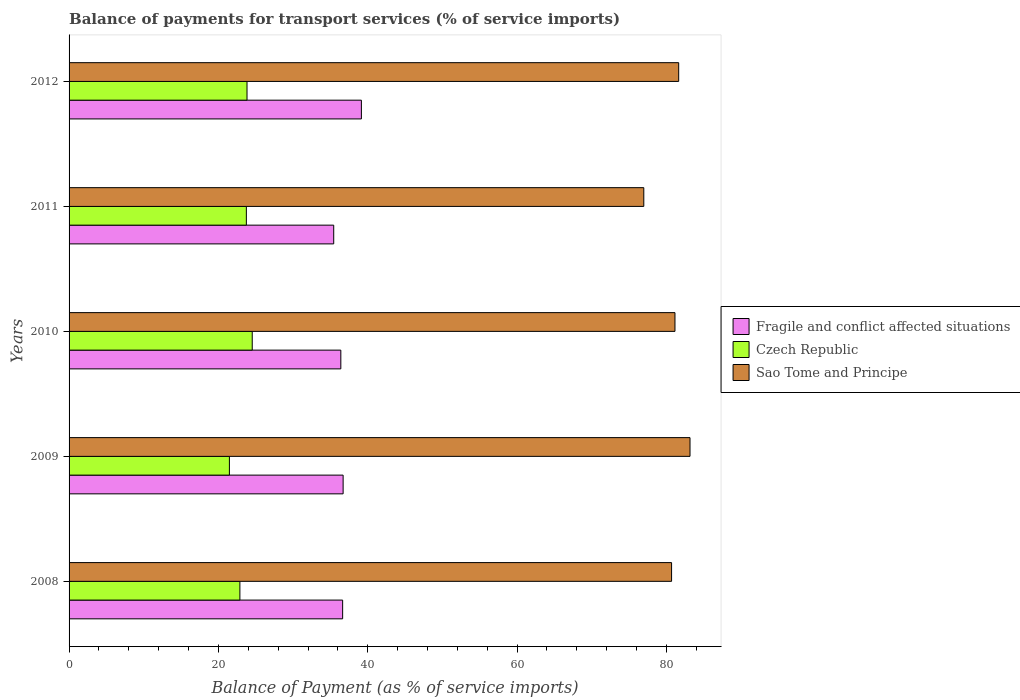Are the number of bars per tick equal to the number of legend labels?
Give a very brief answer. Yes. How many bars are there on the 3rd tick from the top?
Keep it short and to the point. 3. How many bars are there on the 5th tick from the bottom?
Ensure brevity in your answer.  3. What is the balance of payments for transport services in Sao Tome and Principe in 2009?
Offer a very short reply. 83.15. Across all years, what is the maximum balance of payments for transport services in Czech Republic?
Your response must be concise. 24.53. Across all years, what is the minimum balance of payments for transport services in Czech Republic?
Provide a succinct answer. 21.47. What is the total balance of payments for transport services in Fragile and conflict affected situations in the graph?
Your answer should be compact. 184.31. What is the difference between the balance of payments for transport services in Fragile and conflict affected situations in 2009 and that in 2011?
Your answer should be compact. 1.26. What is the difference between the balance of payments for transport services in Sao Tome and Principe in 2009 and the balance of payments for transport services in Czech Republic in 2012?
Your response must be concise. 59.32. What is the average balance of payments for transport services in Sao Tome and Principe per year?
Keep it short and to the point. 80.72. In the year 2009, what is the difference between the balance of payments for transport services in Czech Republic and balance of payments for transport services in Sao Tome and Principe?
Give a very brief answer. -61.68. In how many years, is the balance of payments for transport services in Sao Tome and Principe greater than 64 %?
Offer a terse response. 5. What is the ratio of the balance of payments for transport services in Czech Republic in 2008 to that in 2009?
Offer a very short reply. 1.07. Is the balance of payments for transport services in Czech Republic in 2008 less than that in 2012?
Offer a terse response. Yes. What is the difference between the highest and the second highest balance of payments for transport services in Sao Tome and Principe?
Provide a succinct answer. 1.52. What is the difference between the highest and the lowest balance of payments for transport services in Sao Tome and Principe?
Provide a succinct answer. 6.19. In how many years, is the balance of payments for transport services in Sao Tome and Principe greater than the average balance of payments for transport services in Sao Tome and Principe taken over all years?
Your response must be concise. 3. What does the 1st bar from the top in 2011 represents?
Offer a very short reply. Sao Tome and Principe. What does the 3rd bar from the bottom in 2008 represents?
Give a very brief answer. Sao Tome and Principe. How many bars are there?
Provide a short and direct response. 15. What is the title of the graph?
Keep it short and to the point. Balance of payments for transport services (% of service imports). What is the label or title of the X-axis?
Provide a short and direct response. Balance of Payment (as % of service imports). What is the Balance of Payment (as % of service imports) of Fragile and conflict affected situations in 2008?
Make the answer very short. 36.64. What is the Balance of Payment (as % of service imports) in Czech Republic in 2008?
Your response must be concise. 22.88. What is the Balance of Payment (as % of service imports) of Sao Tome and Principe in 2008?
Provide a short and direct response. 80.69. What is the Balance of Payment (as % of service imports) of Fragile and conflict affected situations in 2009?
Offer a very short reply. 36.7. What is the Balance of Payment (as % of service imports) of Czech Republic in 2009?
Offer a very short reply. 21.47. What is the Balance of Payment (as % of service imports) in Sao Tome and Principe in 2009?
Give a very brief answer. 83.15. What is the Balance of Payment (as % of service imports) in Fragile and conflict affected situations in 2010?
Keep it short and to the point. 36.39. What is the Balance of Payment (as % of service imports) in Czech Republic in 2010?
Offer a terse response. 24.53. What is the Balance of Payment (as % of service imports) in Sao Tome and Principe in 2010?
Your answer should be very brief. 81.14. What is the Balance of Payment (as % of service imports) in Fragile and conflict affected situations in 2011?
Offer a very short reply. 35.44. What is the Balance of Payment (as % of service imports) in Czech Republic in 2011?
Give a very brief answer. 23.74. What is the Balance of Payment (as % of service imports) of Sao Tome and Principe in 2011?
Provide a short and direct response. 76.96. What is the Balance of Payment (as % of service imports) of Fragile and conflict affected situations in 2012?
Provide a short and direct response. 39.15. What is the Balance of Payment (as % of service imports) in Czech Republic in 2012?
Offer a very short reply. 23.83. What is the Balance of Payment (as % of service imports) of Sao Tome and Principe in 2012?
Give a very brief answer. 81.64. Across all years, what is the maximum Balance of Payment (as % of service imports) of Fragile and conflict affected situations?
Your answer should be very brief. 39.15. Across all years, what is the maximum Balance of Payment (as % of service imports) of Czech Republic?
Provide a succinct answer. 24.53. Across all years, what is the maximum Balance of Payment (as % of service imports) of Sao Tome and Principe?
Keep it short and to the point. 83.15. Across all years, what is the minimum Balance of Payment (as % of service imports) of Fragile and conflict affected situations?
Keep it short and to the point. 35.44. Across all years, what is the minimum Balance of Payment (as % of service imports) of Czech Republic?
Your response must be concise. 21.47. Across all years, what is the minimum Balance of Payment (as % of service imports) in Sao Tome and Principe?
Your answer should be compact. 76.96. What is the total Balance of Payment (as % of service imports) in Fragile and conflict affected situations in the graph?
Make the answer very short. 184.31. What is the total Balance of Payment (as % of service imports) in Czech Republic in the graph?
Provide a short and direct response. 116.45. What is the total Balance of Payment (as % of service imports) of Sao Tome and Principe in the graph?
Offer a very short reply. 403.58. What is the difference between the Balance of Payment (as % of service imports) of Fragile and conflict affected situations in 2008 and that in 2009?
Make the answer very short. -0.07. What is the difference between the Balance of Payment (as % of service imports) of Czech Republic in 2008 and that in 2009?
Ensure brevity in your answer.  1.4. What is the difference between the Balance of Payment (as % of service imports) of Sao Tome and Principe in 2008 and that in 2009?
Ensure brevity in your answer.  -2.47. What is the difference between the Balance of Payment (as % of service imports) of Fragile and conflict affected situations in 2008 and that in 2010?
Offer a terse response. 0.24. What is the difference between the Balance of Payment (as % of service imports) of Czech Republic in 2008 and that in 2010?
Give a very brief answer. -1.65. What is the difference between the Balance of Payment (as % of service imports) in Sao Tome and Principe in 2008 and that in 2010?
Make the answer very short. -0.45. What is the difference between the Balance of Payment (as % of service imports) in Fragile and conflict affected situations in 2008 and that in 2011?
Ensure brevity in your answer.  1.2. What is the difference between the Balance of Payment (as % of service imports) in Czech Republic in 2008 and that in 2011?
Make the answer very short. -0.87. What is the difference between the Balance of Payment (as % of service imports) in Sao Tome and Principe in 2008 and that in 2011?
Provide a short and direct response. 3.72. What is the difference between the Balance of Payment (as % of service imports) of Fragile and conflict affected situations in 2008 and that in 2012?
Offer a terse response. -2.51. What is the difference between the Balance of Payment (as % of service imports) of Czech Republic in 2008 and that in 2012?
Your response must be concise. -0.95. What is the difference between the Balance of Payment (as % of service imports) of Sao Tome and Principe in 2008 and that in 2012?
Your answer should be very brief. -0.95. What is the difference between the Balance of Payment (as % of service imports) of Fragile and conflict affected situations in 2009 and that in 2010?
Offer a very short reply. 0.31. What is the difference between the Balance of Payment (as % of service imports) in Czech Republic in 2009 and that in 2010?
Ensure brevity in your answer.  -3.06. What is the difference between the Balance of Payment (as % of service imports) of Sao Tome and Principe in 2009 and that in 2010?
Keep it short and to the point. 2.01. What is the difference between the Balance of Payment (as % of service imports) of Fragile and conflict affected situations in 2009 and that in 2011?
Offer a terse response. 1.26. What is the difference between the Balance of Payment (as % of service imports) in Czech Republic in 2009 and that in 2011?
Your response must be concise. -2.27. What is the difference between the Balance of Payment (as % of service imports) in Sao Tome and Principe in 2009 and that in 2011?
Keep it short and to the point. 6.19. What is the difference between the Balance of Payment (as % of service imports) of Fragile and conflict affected situations in 2009 and that in 2012?
Keep it short and to the point. -2.45. What is the difference between the Balance of Payment (as % of service imports) in Czech Republic in 2009 and that in 2012?
Offer a very short reply. -2.36. What is the difference between the Balance of Payment (as % of service imports) of Sao Tome and Principe in 2009 and that in 2012?
Make the answer very short. 1.52. What is the difference between the Balance of Payment (as % of service imports) in Fragile and conflict affected situations in 2010 and that in 2011?
Provide a succinct answer. 0.95. What is the difference between the Balance of Payment (as % of service imports) of Czech Republic in 2010 and that in 2011?
Provide a succinct answer. 0.79. What is the difference between the Balance of Payment (as % of service imports) of Sao Tome and Principe in 2010 and that in 2011?
Keep it short and to the point. 4.17. What is the difference between the Balance of Payment (as % of service imports) in Fragile and conflict affected situations in 2010 and that in 2012?
Your response must be concise. -2.75. What is the difference between the Balance of Payment (as % of service imports) in Czech Republic in 2010 and that in 2012?
Ensure brevity in your answer.  0.7. What is the difference between the Balance of Payment (as % of service imports) in Sao Tome and Principe in 2010 and that in 2012?
Make the answer very short. -0.5. What is the difference between the Balance of Payment (as % of service imports) of Fragile and conflict affected situations in 2011 and that in 2012?
Make the answer very short. -3.71. What is the difference between the Balance of Payment (as % of service imports) of Czech Republic in 2011 and that in 2012?
Your answer should be compact. -0.09. What is the difference between the Balance of Payment (as % of service imports) of Sao Tome and Principe in 2011 and that in 2012?
Offer a terse response. -4.67. What is the difference between the Balance of Payment (as % of service imports) in Fragile and conflict affected situations in 2008 and the Balance of Payment (as % of service imports) in Czech Republic in 2009?
Keep it short and to the point. 15.16. What is the difference between the Balance of Payment (as % of service imports) in Fragile and conflict affected situations in 2008 and the Balance of Payment (as % of service imports) in Sao Tome and Principe in 2009?
Your answer should be compact. -46.52. What is the difference between the Balance of Payment (as % of service imports) of Czech Republic in 2008 and the Balance of Payment (as % of service imports) of Sao Tome and Principe in 2009?
Offer a very short reply. -60.28. What is the difference between the Balance of Payment (as % of service imports) in Fragile and conflict affected situations in 2008 and the Balance of Payment (as % of service imports) in Czech Republic in 2010?
Provide a succinct answer. 12.11. What is the difference between the Balance of Payment (as % of service imports) in Fragile and conflict affected situations in 2008 and the Balance of Payment (as % of service imports) in Sao Tome and Principe in 2010?
Your answer should be compact. -44.5. What is the difference between the Balance of Payment (as % of service imports) of Czech Republic in 2008 and the Balance of Payment (as % of service imports) of Sao Tome and Principe in 2010?
Your answer should be compact. -58.26. What is the difference between the Balance of Payment (as % of service imports) of Fragile and conflict affected situations in 2008 and the Balance of Payment (as % of service imports) of Czech Republic in 2011?
Your answer should be very brief. 12.89. What is the difference between the Balance of Payment (as % of service imports) in Fragile and conflict affected situations in 2008 and the Balance of Payment (as % of service imports) in Sao Tome and Principe in 2011?
Offer a very short reply. -40.33. What is the difference between the Balance of Payment (as % of service imports) of Czech Republic in 2008 and the Balance of Payment (as % of service imports) of Sao Tome and Principe in 2011?
Make the answer very short. -54.09. What is the difference between the Balance of Payment (as % of service imports) in Fragile and conflict affected situations in 2008 and the Balance of Payment (as % of service imports) in Czech Republic in 2012?
Keep it short and to the point. 12.81. What is the difference between the Balance of Payment (as % of service imports) in Fragile and conflict affected situations in 2008 and the Balance of Payment (as % of service imports) in Sao Tome and Principe in 2012?
Provide a succinct answer. -45. What is the difference between the Balance of Payment (as % of service imports) in Czech Republic in 2008 and the Balance of Payment (as % of service imports) in Sao Tome and Principe in 2012?
Offer a terse response. -58.76. What is the difference between the Balance of Payment (as % of service imports) of Fragile and conflict affected situations in 2009 and the Balance of Payment (as % of service imports) of Czech Republic in 2010?
Keep it short and to the point. 12.17. What is the difference between the Balance of Payment (as % of service imports) of Fragile and conflict affected situations in 2009 and the Balance of Payment (as % of service imports) of Sao Tome and Principe in 2010?
Keep it short and to the point. -44.44. What is the difference between the Balance of Payment (as % of service imports) of Czech Republic in 2009 and the Balance of Payment (as % of service imports) of Sao Tome and Principe in 2010?
Ensure brevity in your answer.  -59.67. What is the difference between the Balance of Payment (as % of service imports) in Fragile and conflict affected situations in 2009 and the Balance of Payment (as % of service imports) in Czech Republic in 2011?
Offer a very short reply. 12.96. What is the difference between the Balance of Payment (as % of service imports) of Fragile and conflict affected situations in 2009 and the Balance of Payment (as % of service imports) of Sao Tome and Principe in 2011?
Provide a succinct answer. -40.26. What is the difference between the Balance of Payment (as % of service imports) of Czech Republic in 2009 and the Balance of Payment (as % of service imports) of Sao Tome and Principe in 2011?
Your answer should be compact. -55.49. What is the difference between the Balance of Payment (as % of service imports) of Fragile and conflict affected situations in 2009 and the Balance of Payment (as % of service imports) of Czech Republic in 2012?
Your answer should be compact. 12.87. What is the difference between the Balance of Payment (as % of service imports) of Fragile and conflict affected situations in 2009 and the Balance of Payment (as % of service imports) of Sao Tome and Principe in 2012?
Provide a short and direct response. -44.94. What is the difference between the Balance of Payment (as % of service imports) of Czech Republic in 2009 and the Balance of Payment (as % of service imports) of Sao Tome and Principe in 2012?
Your response must be concise. -60.17. What is the difference between the Balance of Payment (as % of service imports) of Fragile and conflict affected situations in 2010 and the Balance of Payment (as % of service imports) of Czech Republic in 2011?
Your response must be concise. 12.65. What is the difference between the Balance of Payment (as % of service imports) in Fragile and conflict affected situations in 2010 and the Balance of Payment (as % of service imports) in Sao Tome and Principe in 2011?
Make the answer very short. -40.57. What is the difference between the Balance of Payment (as % of service imports) in Czech Republic in 2010 and the Balance of Payment (as % of service imports) in Sao Tome and Principe in 2011?
Your response must be concise. -52.44. What is the difference between the Balance of Payment (as % of service imports) in Fragile and conflict affected situations in 2010 and the Balance of Payment (as % of service imports) in Czech Republic in 2012?
Provide a short and direct response. 12.56. What is the difference between the Balance of Payment (as % of service imports) in Fragile and conflict affected situations in 2010 and the Balance of Payment (as % of service imports) in Sao Tome and Principe in 2012?
Make the answer very short. -45.24. What is the difference between the Balance of Payment (as % of service imports) of Czech Republic in 2010 and the Balance of Payment (as % of service imports) of Sao Tome and Principe in 2012?
Offer a terse response. -57.11. What is the difference between the Balance of Payment (as % of service imports) in Fragile and conflict affected situations in 2011 and the Balance of Payment (as % of service imports) in Czech Republic in 2012?
Ensure brevity in your answer.  11.61. What is the difference between the Balance of Payment (as % of service imports) of Fragile and conflict affected situations in 2011 and the Balance of Payment (as % of service imports) of Sao Tome and Principe in 2012?
Provide a succinct answer. -46.2. What is the difference between the Balance of Payment (as % of service imports) of Czech Republic in 2011 and the Balance of Payment (as % of service imports) of Sao Tome and Principe in 2012?
Provide a short and direct response. -57.89. What is the average Balance of Payment (as % of service imports) in Fragile and conflict affected situations per year?
Your answer should be compact. 36.86. What is the average Balance of Payment (as % of service imports) in Czech Republic per year?
Provide a short and direct response. 23.29. What is the average Balance of Payment (as % of service imports) of Sao Tome and Principe per year?
Offer a terse response. 80.72. In the year 2008, what is the difference between the Balance of Payment (as % of service imports) of Fragile and conflict affected situations and Balance of Payment (as % of service imports) of Czech Republic?
Keep it short and to the point. 13.76. In the year 2008, what is the difference between the Balance of Payment (as % of service imports) of Fragile and conflict affected situations and Balance of Payment (as % of service imports) of Sao Tome and Principe?
Your answer should be very brief. -44.05. In the year 2008, what is the difference between the Balance of Payment (as % of service imports) of Czech Republic and Balance of Payment (as % of service imports) of Sao Tome and Principe?
Offer a very short reply. -57.81. In the year 2009, what is the difference between the Balance of Payment (as % of service imports) of Fragile and conflict affected situations and Balance of Payment (as % of service imports) of Czech Republic?
Offer a very short reply. 15.23. In the year 2009, what is the difference between the Balance of Payment (as % of service imports) in Fragile and conflict affected situations and Balance of Payment (as % of service imports) in Sao Tome and Principe?
Your response must be concise. -46.45. In the year 2009, what is the difference between the Balance of Payment (as % of service imports) of Czech Republic and Balance of Payment (as % of service imports) of Sao Tome and Principe?
Make the answer very short. -61.68. In the year 2010, what is the difference between the Balance of Payment (as % of service imports) of Fragile and conflict affected situations and Balance of Payment (as % of service imports) of Czech Republic?
Your answer should be compact. 11.87. In the year 2010, what is the difference between the Balance of Payment (as % of service imports) of Fragile and conflict affected situations and Balance of Payment (as % of service imports) of Sao Tome and Principe?
Your answer should be very brief. -44.75. In the year 2010, what is the difference between the Balance of Payment (as % of service imports) of Czech Republic and Balance of Payment (as % of service imports) of Sao Tome and Principe?
Your answer should be very brief. -56.61. In the year 2011, what is the difference between the Balance of Payment (as % of service imports) of Fragile and conflict affected situations and Balance of Payment (as % of service imports) of Czech Republic?
Ensure brevity in your answer.  11.7. In the year 2011, what is the difference between the Balance of Payment (as % of service imports) in Fragile and conflict affected situations and Balance of Payment (as % of service imports) in Sao Tome and Principe?
Provide a succinct answer. -41.53. In the year 2011, what is the difference between the Balance of Payment (as % of service imports) in Czech Republic and Balance of Payment (as % of service imports) in Sao Tome and Principe?
Your answer should be very brief. -53.22. In the year 2012, what is the difference between the Balance of Payment (as % of service imports) in Fragile and conflict affected situations and Balance of Payment (as % of service imports) in Czech Republic?
Provide a short and direct response. 15.32. In the year 2012, what is the difference between the Balance of Payment (as % of service imports) of Fragile and conflict affected situations and Balance of Payment (as % of service imports) of Sao Tome and Principe?
Offer a very short reply. -42.49. In the year 2012, what is the difference between the Balance of Payment (as % of service imports) in Czech Republic and Balance of Payment (as % of service imports) in Sao Tome and Principe?
Make the answer very short. -57.81. What is the ratio of the Balance of Payment (as % of service imports) in Fragile and conflict affected situations in 2008 to that in 2009?
Your answer should be compact. 1. What is the ratio of the Balance of Payment (as % of service imports) in Czech Republic in 2008 to that in 2009?
Your answer should be compact. 1.07. What is the ratio of the Balance of Payment (as % of service imports) in Sao Tome and Principe in 2008 to that in 2009?
Offer a terse response. 0.97. What is the ratio of the Balance of Payment (as % of service imports) of Fragile and conflict affected situations in 2008 to that in 2010?
Provide a succinct answer. 1.01. What is the ratio of the Balance of Payment (as % of service imports) in Czech Republic in 2008 to that in 2010?
Keep it short and to the point. 0.93. What is the ratio of the Balance of Payment (as % of service imports) in Fragile and conflict affected situations in 2008 to that in 2011?
Give a very brief answer. 1.03. What is the ratio of the Balance of Payment (as % of service imports) in Czech Republic in 2008 to that in 2011?
Make the answer very short. 0.96. What is the ratio of the Balance of Payment (as % of service imports) in Sao Tome and Principe in 2008 to that in 2011?
Provide a succinct answer. 1.05. What is the ratio of the Balance of Payment (as % of service imports) of Fragile and conflict affected situations in 2008 to that in 2012?
Your answer should be compact. 0.94. What is the ratio of the Balance of Payment (as % of service imports) of Czech Republic in 2008 to that in 2012?
Your answer should be very brief. 0.96. What is the ratio of the Balance of Payment (as % of service imports) of Sao Tome and Principe in 2008 to that in 2012?
Keep it short and to the point. 0.99. What is the ratio of the Balance of Payment (as % of service imports) of Fragile and conflict affected situations in 2009 to that in 2010?
Provide a succinct answer. 1.01. What is the ratio of the Balance of Payment (as % of service imports) in Czech Republic in 2009 to that in 2010?
Ensure brevity in your answer.  0.88. What is the ratio of the Balance of Payment (as % of service imports) of Sao Tome and Principe in 2009 to that in 2010?
Your answer should be compact. 1.02. What is the ratio of the Balance of Payment (as % of service imports) of Fragile and conflict affected situations in 2009 to that in 2011?
Your answer should be compact. 1.04. What is the ratio of the Balance of Payment (as % of service imports) of Czech Republic in 2009 to that in 2011?
Your answer should be very brief. 0.9. What is the ratio of the Balance of Payment (as % of service imports) in Sao Tome and Principe in 2009 to that in 2011?
Your answer should be compact. 1.08. What is the ratio of the Balance of Payment (as % of service imports) of Fragile and conflict affected situations in 2009 to that in 2012?
Your answer should be compact. 0.94. What is the ratio of the Balance of Payment (as % of service imports) of Czech Republic in 2009 to that in 2012?
Your answer should be very brief. 0.9. What is the ratio of the Balance of Payment (as % of service imports) in Sao Tome and Principe in 2009 to that in 2012?
Keep it short and to the point. 1.02. What is the ratio of the Balance of Payment (as % of service imports) of Fragile and conflict affected situations in 2010 to that in 2011?
Your answer should be very brief. 1.03. What is the ratio of the Balance of Payment (as % of service imports) in Czech Republic in 2010 to that in 2011?
Offer a terse response. 1.03. What is the ratio of the Balance of Payment (as % of service imports) of Sao Tome and Principe in 2010 to that in 2011?
Offer a terse response. 1.05. What is the ratio of the Balance of Payment (as % of service imports) in Fragile and conflict affected situations in 2010 to that in 2012?
Provide a succinct answer. 0.93. What is the ratio of the Balance of Payment (as % of service imports) in Czech Republic in 2010 to that in 2012?
Provide a succinct answer. 1.03. What is the ratio of the Balance of Payment (as % of service imports) in Sao Tome and Principe in 2010 to that in 2012?
Keep it short and to the point. 0.99. What is the ratio of the Balance of Payment (as % of service imports) in Fragile and conflict affected situations in 2011 to that in 2012?
Provide a succinct answer. 0.91. What is the ratio of the Balance of Payment (as % of service imports) of Czech Republic in 2011 to that in 2012?
Your response must be concise. 1. What is the ratio of the Balance of Payment (as % of service imports) in Sao Tome and Principe in 2011 to that in 2012?
Offer a very short reply. 0.94. What is the difference between the highest and the second highest Balance of Payment (as % of service imports) of Fragile and conflict affected situations?
Offer a very short reply. 2.45. What is the difference between the highest and the second highest Balance of Payment (as % of service imports) of Czech Republic?
Provide a short and direct response. 0.7. What is the difference between the highest and the second highest Balance of Payment (as % of service imports) in Sao Tome and Principe?
Give a very brief answer. 1.52. What is the difference between the highest and the lowest Balance of Payment (as % of service imports) in Fragile and conflict affected situations?
Your answer should be very brief. 3.71. What is the difference between the highest and the lowest Balance of Payment (as % of service imports) of Czech Republic?
Make the answer very short. 3.06. What is the difference between the highest and the lowest Balance of Payment (as % of service imports) of Sao Tome and Principe?
Give a very brief answer. 6.19. 